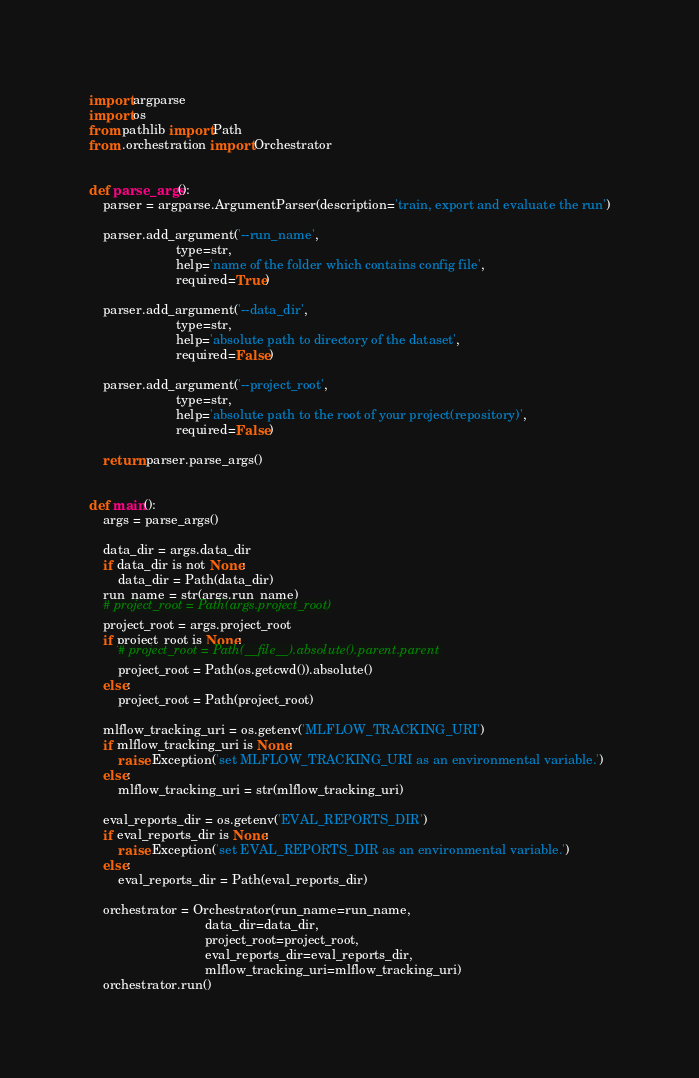Convert code to text. <code><loc_0><loc_0><loc_500><loc_500><_Python_>import argparse
import os
from pathlib import Path
from .orchestration import Orchestrator


def parse_args():
    parser = argparse.ArgumentParser(description='train, export and evaluate the run')

    parser.add_argument('--run_name',
                        type=str,
                        help='name of the folder which contains config file',
                        required=True)

    parser.add_argument('--data_dir',
                        type=str,
                        help='absolute path to directory of the dataset',
                        required=False)

    parser.add_argument('--project_root',
                        type=str,
                        help='absolute path to the root of your project(repository)',
                        required=False)

    return parser.parse_args()


def main():
    args = parse_args()

    data_dir = args.data_dir
    if data_dir is not None:
        data_dir = Path(data_dir)
    run_name = str(args.run_name)
    # project_root = Path(args.project_root)
    project_root = args.project_root
    if project_root is None:
        # project_root = Path(__file__).absolute().parent.parent
        project_root = Path(os.getcwd()).absolute()
    else:
        project_root = Path(project_root)

    mlflow_tracking_uri = os.getenv('MLFLOW_TRACKING_URI')
    if mlflow_tracking_uri is None:
        raise Exception('set MLFLOW_TRACKING_URI as an environmental variable.')
    else:
        mlflow_tracking_uri = str(mlflow_tracking_uri)

    eval_reports_dir = os.getenv('EVAL_REPORTS_DIR')
    if eval_reports_dir is None:
        raise Exception('set EVAL_REPORTS_DIR as an environmental variable.')
    else:
        eval_reports_dir = Path(eval_reports_dir)

    orchestrator = Orchestrator(run_name=run_name,
                                data_dir=data_dir,
                                project_root=project_root,
                                eval_reports_dir=eval_reports_dir,
                                mlflow_tracking_uri=mlflow_tracking_uri)
    orchestrator.run()
</code> 